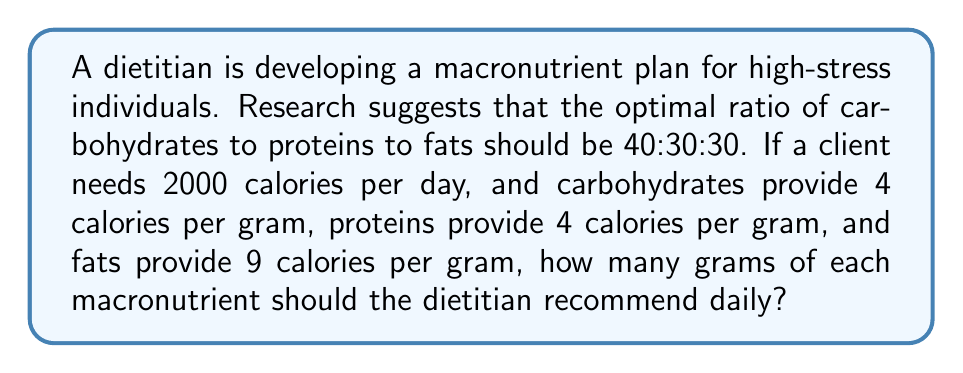Can you solve this math problem? Let's approach this step-by-step:

1) First, we need to calculate the number of calories that should come from each macronutrient:

   Carbohydrates: $40\% \times 2000 = 800$ calories
   Proteins: $30\% \times 2000 = 600$ calories
   Fats: $30\% \times 2000 = 600$ calories

2) Now, we need to convert these calorie amounts to grams. We'll use the given information about calories per gram:

   For Carbohydrates:
   $$\frac{800 \text{ calories}}{4 \text{ calories/gram}} = 200 \text{ grams}$$

   For Proteins:
   $$\frac{600 \text{ calories}}{4 \text{ calories/gram}} = 150 \text{ grams}$$

   For Fats:
   $$\frac{600 \text{ calories}}{9 \text{ calories/gram}} \approx 66.67 \text{ grams}$$

3) We can round the fat grams to the nearest whole number: 67 grams.

Therefore, the dietitian should recommend 200 grams of carbohydrates, 150 grams of proteins, and 67 grams of fats daily.
Answer: 200 grams of carbohydrates, 150 grams of proteins, and 67 grams of fats. 